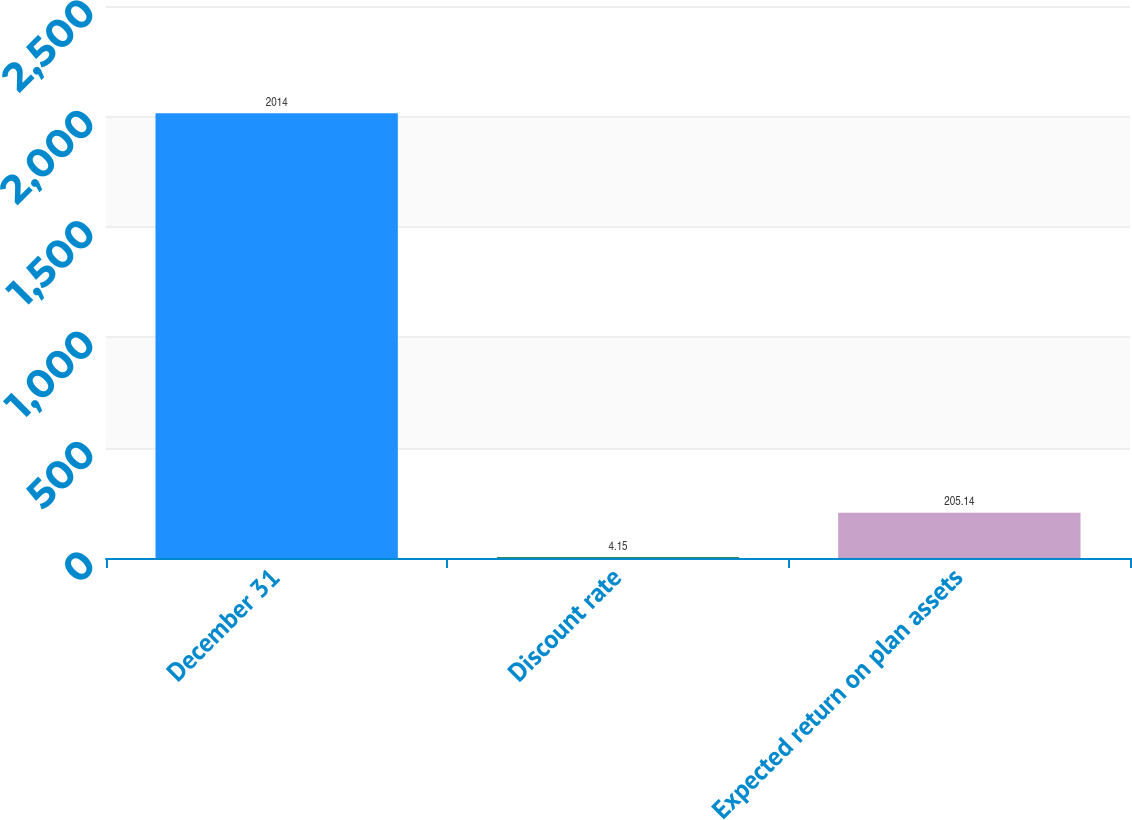Convert chart. <chart><loc_0><loc_0><loc_500><loc_500><bar_chart><fcel>December 31<fcel>Discount rate<fcel>Expected return on plan assets<nl><fcel>2014<fcel>4.15<fcel>205.14<nl></chart> 